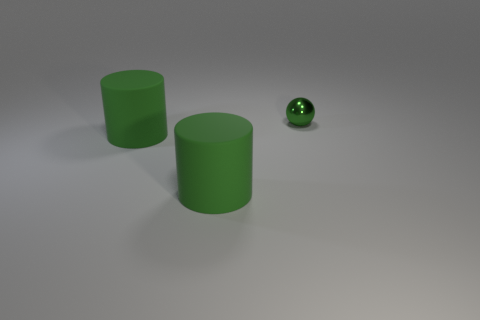Add 1 matte cylinders. How many objects exist? 4 Subtract all balls. How many objects are left? 2 Subtract all big metal spheres. Subtract all big green objects. How many objects are left? 1 Add 3 small green things. How many small green things are left? 4 Add 3 large things. How many large things exist? 5 Subtract 0 brown cubes. How many objects are left? 3 